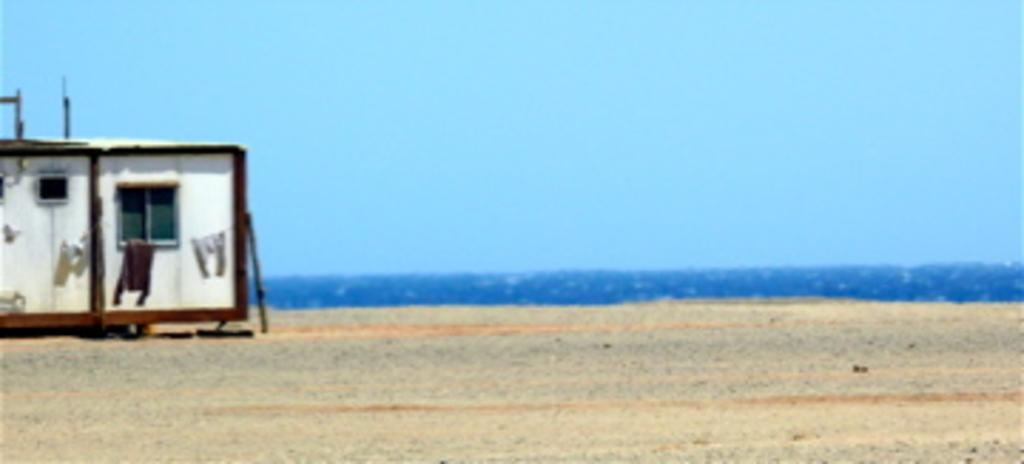What is the location of the image in relation to a natural feature? The image is near the ocean. What type of terrain is visible at the bottom of the image? There is sand at the bottom of the image. What structure is located on the left side of the image? There is a cabin with a window on the left side of the image. What is visible at the top of the image? The sky is visible at the top of the image. What type of jam is being spread on the line in the image? There is no jam or line present in the image. How many people are laughing in the image? There are no people laughing in the image. 